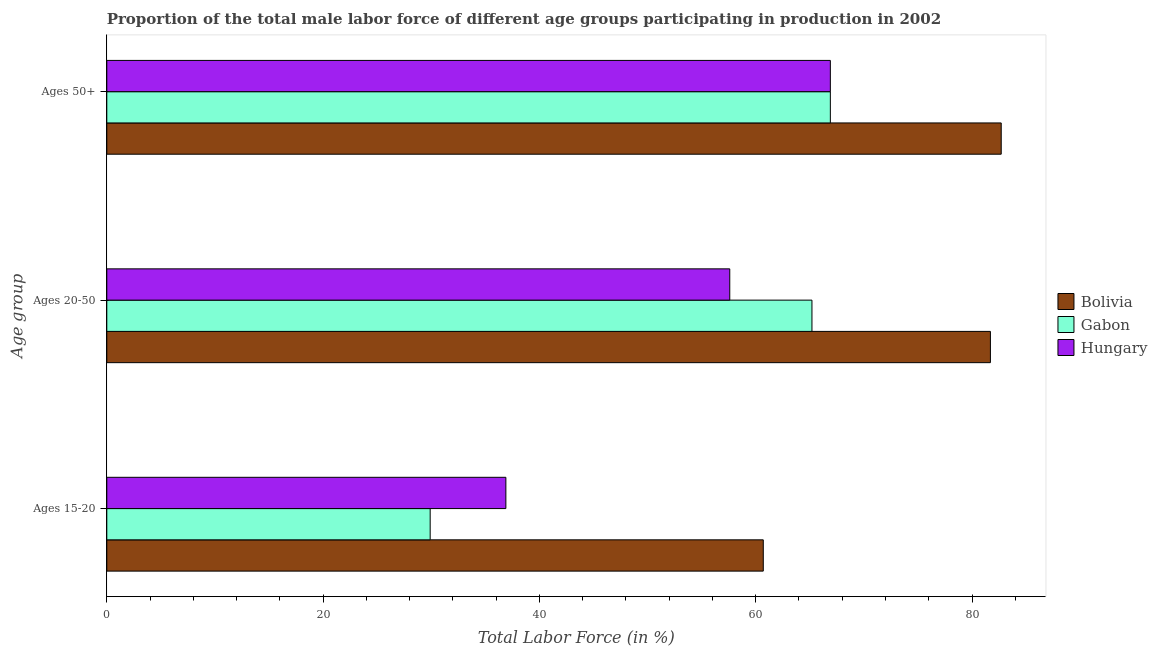Are the number of bars per tick equal to the number of legend labels?
Ensure brevity in your answer.  Yes. Are the number of bars on each tick of the Y-axis equal?
Your answer should be compact. Yes. How many bars are there on the 2nd tick from the top?
Provide a succinct answer. 3. How many bars are there on the 2nd tick from the bottom?
Your answer should be compact. 3. What is the label of the 1st group of bars from the top?
Your response must be concise. Ages 50+. What is the percentage of male labor force above age 50 in Gabon?
Give a very brief answer. 66.9. Across all countries, what is the maximum percentage of male labor force within the age group 20-50?
Offer a very short reply. 81.7. Across all countries, what is the minimum percentage of male labor force within the age group 20-50?
Offer a terse response. 57.6. In which country was the percentage of male labor force within the age group 20-50 maximum?
Offer a terse response. Bolivia. In which country was the percentage of male labor force above age 50 minimum?
Provide a short and direct response. Gabon. What is the total percentage of male labor force within the age group 20-50 in the graph?
Make the answer very short. 204.5. What is the difference between the percentage of male labor force within the age group 20-50 in Hungary and that in Bolivia?
Offer a very short reply. -24.1. What is the difference between the percentage of male labor force within the age group 15-20 in Hungary and the percentage of male labor force within the age group 20-50 in Gabon?
Offer a terse response. -28.3. What is the average percentage of male labor force within the age group 15-20 per country?
Provide a short and direct response. 42.5. What is the difference between the percentage of male labor force within the age group 20-50 and percentage of male labor force above age 50 in Bolivia?
Your answer should be very brief. -1. In how many countries, is the percentage of male labor force within the age group 15-20 greater than 44 %?
Give a very brief answer. 1. What is the ratio of the percentage of male labor force above age 50 in Hungary to that in Bolivia?
Make the answer very short. 0.81. Is the percentage of male labor force within the age group 15-20 in Bolivia less than that in Gabon?
Your answer should be very brief. No. Is the difference between the percentage of male labor force within the age group 15-20 in Hungary and Gabon greater than the difference between the percentage of male labor force above age 50 in Hungary and Gabon?
Provide a short and direct response. Yes. What is the difference between the highest and the second highest percentage of male labor force within the age group 15-20?
Offer a terse response. 23.8. What is the difference between the highest and the lowest percentage of male labor force within the age group 15-20?
Your response must be concise. 30.8. Is the sum of the percentage of male labor force within the age group 15-20 in Hungary and Bolivia greater than the maximum percentage of male labor force within the age group 20-50 across all countries?
Provide a short and direct response. Yes. What does the 3rd bar from the top in Ages 50+ represents?
Your response must be concise. Bolivia. What does the 2nd bar from the bottom in Ages 50+ represents?
Offer a terse response. Gabon. Is it the case that in every country, the sum of the percentage of male labor force within the age group 15-20 and percentage of male labor force within the age group 20-50 is greater than the percentage of male labor force above age 50?
Your answer should be very brief. Yes. How many bars are there?
Provide a succinct answer. 9. Are all the bars in the graph horizontal?
Ensure brevity in your answer.  Yes. Are the values on the major ticks of X-axis written in scientific E-notation?
Your answer should be very brief. No. Does the graph contain any zero values?
Ensure brevity in your answer.  No. Does the graph contain grids?
Make the answer very short. No. Where does the legend appear in the graph?
Keep it short and to the point. Center right. How many legend labels are there?
Your response must be concise. 3. What is the title of the graph?
Give a very brief answer. Proportion of the total male labor force of different age groups participating in production in 2002. Does "Bolivia" appear as one of the legend labels in the graph?
Ensure brevity in your answer.  Yes. What is the label or title of the Y-axis?
Give a very brief answer. Age group. What is the Total Labor Force (in %) of Bolivia in Ages 15-20?
Make the answer very short. 60.7. What is the Total Labor Force (in %) of Gabon in Ages 15-20?
Provide a succinct answer. 29.9. What is the Total Labor Force (in %) in Hungary in Ages 15-20?
Make the answer very short. 36.9. What is the Total Labor Force (in %) of Bolivia in Ages 20-50?
Ensure brevity in your answer.  81.7. What is the Total Labor Force (in %) in Gabon in Ages 20-50?
Your answer should be very brief. 65.2. What is the Total Labor Force (in %) of Hungary in Ages 20-50?
Your answer should be compact. 57.6. What is the Total Labor Force (in %) of Bolivia in Ages 50+?
Your response must be concise. 82.7. What is the Total Labor Force (in %) of Gabon in Ages 50+?
Give a very brief answer. 66.9. What is the Total Labor Force (in %) of Hungary in Ages 50+?
Offer a terse response. 66.9. Across all Age group, what is the maximum Total Labor Force (in %) of Bolivia?
Offer a terse response. 82.7. Across all Age group, what is the maximum Total Labor Force (in %) of Gabon?
Offer a very short reply. 66.9. Across all Age group, what is the maximum Total Labor Force (in %) of Hungary?
Your response must be concise. 66.9. Across all Age group, what is the minimum Total Labor Force (in %) in Bolivia?
Give a very brief answer. 60.7. Across all Age group, what is the minimum Total Labor Force (in %) in Gabon?
Ensure brevity in your answer.  29.9. Across all Age group, what is the minimum Total Labor Force (in %) of Hungary?
Your response must be concise. 36.9. What is the total Total Labor Force (in %) in Bolivia in the graph?
Keep it short and to the point. 225.1. What is the total Total Labor Force (in %) of Gabon in the graph?
Your answer should be very brief. 162. What is the total Total Labor Force (in %) of Hungary in the graph?
Offer a terse response. 161.4. What is the difference between the Total Labor Force (in %) in Bolivia in Ages 15-20 and that in Ages 20-50?
Your answer should be very brief. -21. What is the difference between the Total Labor Force (in %) of Gabon in Ages 15-20 and that in Ages 20-50?
Keep it short and to the point. -35.3. What is the difference between the Total Labor Force (in %) of Hungary in Ages 15-20 and that in Ages 20-50?
Ensure brevity in your answer.  -20.7. What is the difference between the Total Labor Force (in %) in Bolivia in Ages 15-20 and that in Ages 50+?
Give a very brief answer. -22. What is the difference between the Total Labor Force (in %) of Gabon in Ages 15-20 and that in Ages 50+?
Provide a succinct answer. -37. What is the difference between the Total Labor Force (in %) of Hungary in Ages 15-20 and that in Ages 50+?
Ensure brevity in your answer.  -30. What is the difference between the Total Labor Force (in %) of Bolivia in Ages 20-50 and that in Ages 50+?
Ensure brevity in your answer.  -1. What is the difference between the Total Labor Force (in %) in Hungary in Ages 20-50 and that in Ages 50+?
Your response must be concise. -9.3. What is the difference between the Total Labor Force (in %) of Bolivia in Ages 15-20 and the Total Labor Force (in %) of Gabon in Ages 20-50?
Provide a succinct answer. -4.5. What is the difference between the Total Labor Force (in %) of Gabon in Ages 15-20 and the Total Labor Force (in %) of Hungary in Ages 20-50?
Provide a succinct answer. -27.7. What is the difference between the Total Labor Force (in %) in Gabon in Ages 15-20 and the Total Labor Force (in %) in Hungary in Ages 50+?
Provide a succinct answer. -37. What is the difference between the Total Labor Force (in %) of Bolivia in Ages 20-50 and the Total Labor Force (in %) of Hungary in Ages 50+?
Provide a short and direct response. 14.8. What is the difference between the Total Labor Force (in %) in Gabon in Ages 20-50 and the Total Labor Force (in %) in Hungary in Ages 50+?
Give a very brief answer. -1.7. What is the average Total Labor Force (in %) in Bolivia per Age group?
Your response must be concise. 75.03. What is the average Total Labor Force (in %) of Hungary per Age group?
Make the answer very short. 53.8. What is the difference between the Total Labor Force (in %) of Bolivia and Total Labor Force (in %) of Gabon in Ages 15-20?
Your answer should be compact. 30.8. What is the difference between the Total Labor Force (in %) of Bolivia and Total Labor Force (in %) of Hungary in Ages 15-20?
Provide a succinct answer. 23.8. What is the difference between the Total Labor Force (in %) of Bolivia and Total Labor Force (in %) of Hungary in Ages 20-50?
Your answer should be compact. 24.1. What is the difference between the Total Labor Force (in %) of Bolivia and Total Labor Force (in %) of Hungary in Ages 50+?
Give a very brief answer. 15.8. What is the ratio of the Total Labor Force (in %) of Bolivia in Ages 15-20 to that in Ages 20-50?
Provide a short and direct response. 0.74. What is the ratio of the Total Labor Force (in %) in Gabon in Ages 15-20 to that in Ages 20-50?
Provide a succinct answer. 0.46. What is the ratio of the Total Labor Force (in %) in Hungary in Ages 15-20 to that in Ages 20-50?
Keep it short and to the point. 0.64. What is the ratio of the Total Labor Force (in %) of Bolivia in Ages 15-20 to that in Ages 50+?
Make the answer very short. 0.73. What is the ratio of the Total Labor Force (in %) of Gabon in Ages 15-20 to that in Ages 50+?
Give a very brief answer. 0.45. What is the ratio of the Total Labor Force (in %) in Hungary in Ages 15-20 to that in Ages 50+?
Provide a short and direct response. 0.55. What is the ratio of the Total Labor Force (in %) in Bolivia in Ages 20-50 to that in Ages 50+?
Make the answer very short. 0.99. What is the ratio of the Total Labor Force (in %) of Gabon in Ages 20-50 to that in Ages 50+?
Offer a very short reply. 0.97. What is the ratio of the Total Labor Force (in %) of Hungary in Ages 20-50 to that in Ages 50+?
Your answer should be compact. 0.86. What is the difference between the highest and the second highest Total Labor Force (in %) of Gabon?
Make the answer very short. 1.7. What is the difference between the highest and the lowest Total Labor Force (in %) of Gabon?
Ensure brevity in your answer.  37. 